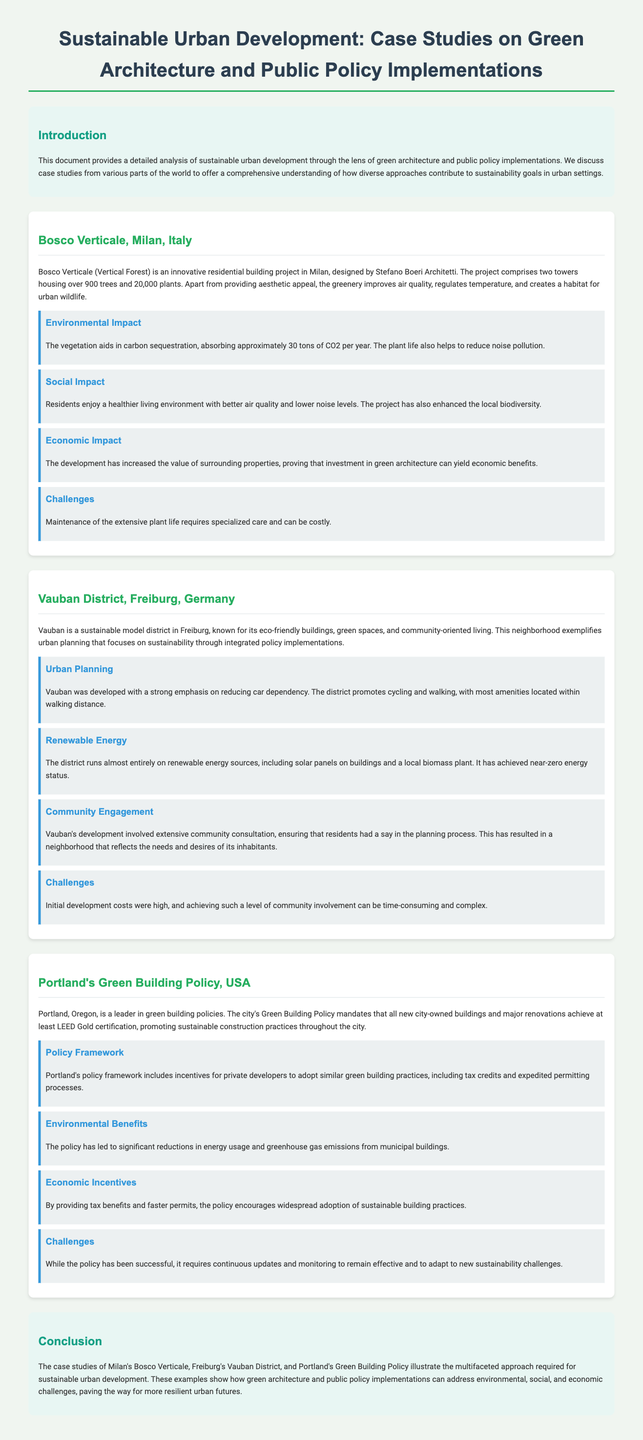What is the name of the residential building project in Milan? The document states that the residential building project in Milan is called Bosco Verticale.
Answer: Bosco Verticale How many trees are included in Bosco Verticale? The document mentions that Bosco Verticale houses over 900 trees.
Answer: 900 trees What was the focus of the urban planning in Vauban District? The document indicates that Vauban District was developed with a strong emphasis on reducing car dependency.
Answer: Reducing car dependency What is the near-zero energy status achieved by Vauban based on? The document explains that the district runs almost entirely on renewable energy sources, including solar panels and a biomass plant.
Answer: Renewable energy sources What certification is required by Portland's Green Building Policy for new city-owned buildings? According to the document, all new city-owned buildings must achieve at least LEED Gold certification.
Answer: LEED Gold certification What benefit does Portland provide to private developers under its Green Building Policy? The document states that Portland offers incentives for private developers, including tax credits.
Answer: Tax credits What is one economic impact of the Bosco Verticale project? The document states that the development has increased the value of surrounding properties.
Answer: Increased value of surrounding properties What challenge does the Bosco Verticale face? According to the document, maintenance of the extensive plant life requires specialized care and can be costly.
Answer: Specialized care and cost What is a major community engagement aspect of Vauban's development? The document highlights that the development involved extensive community consultation, ensuring residents had a say in the planning process.
Answer: Community consultation 